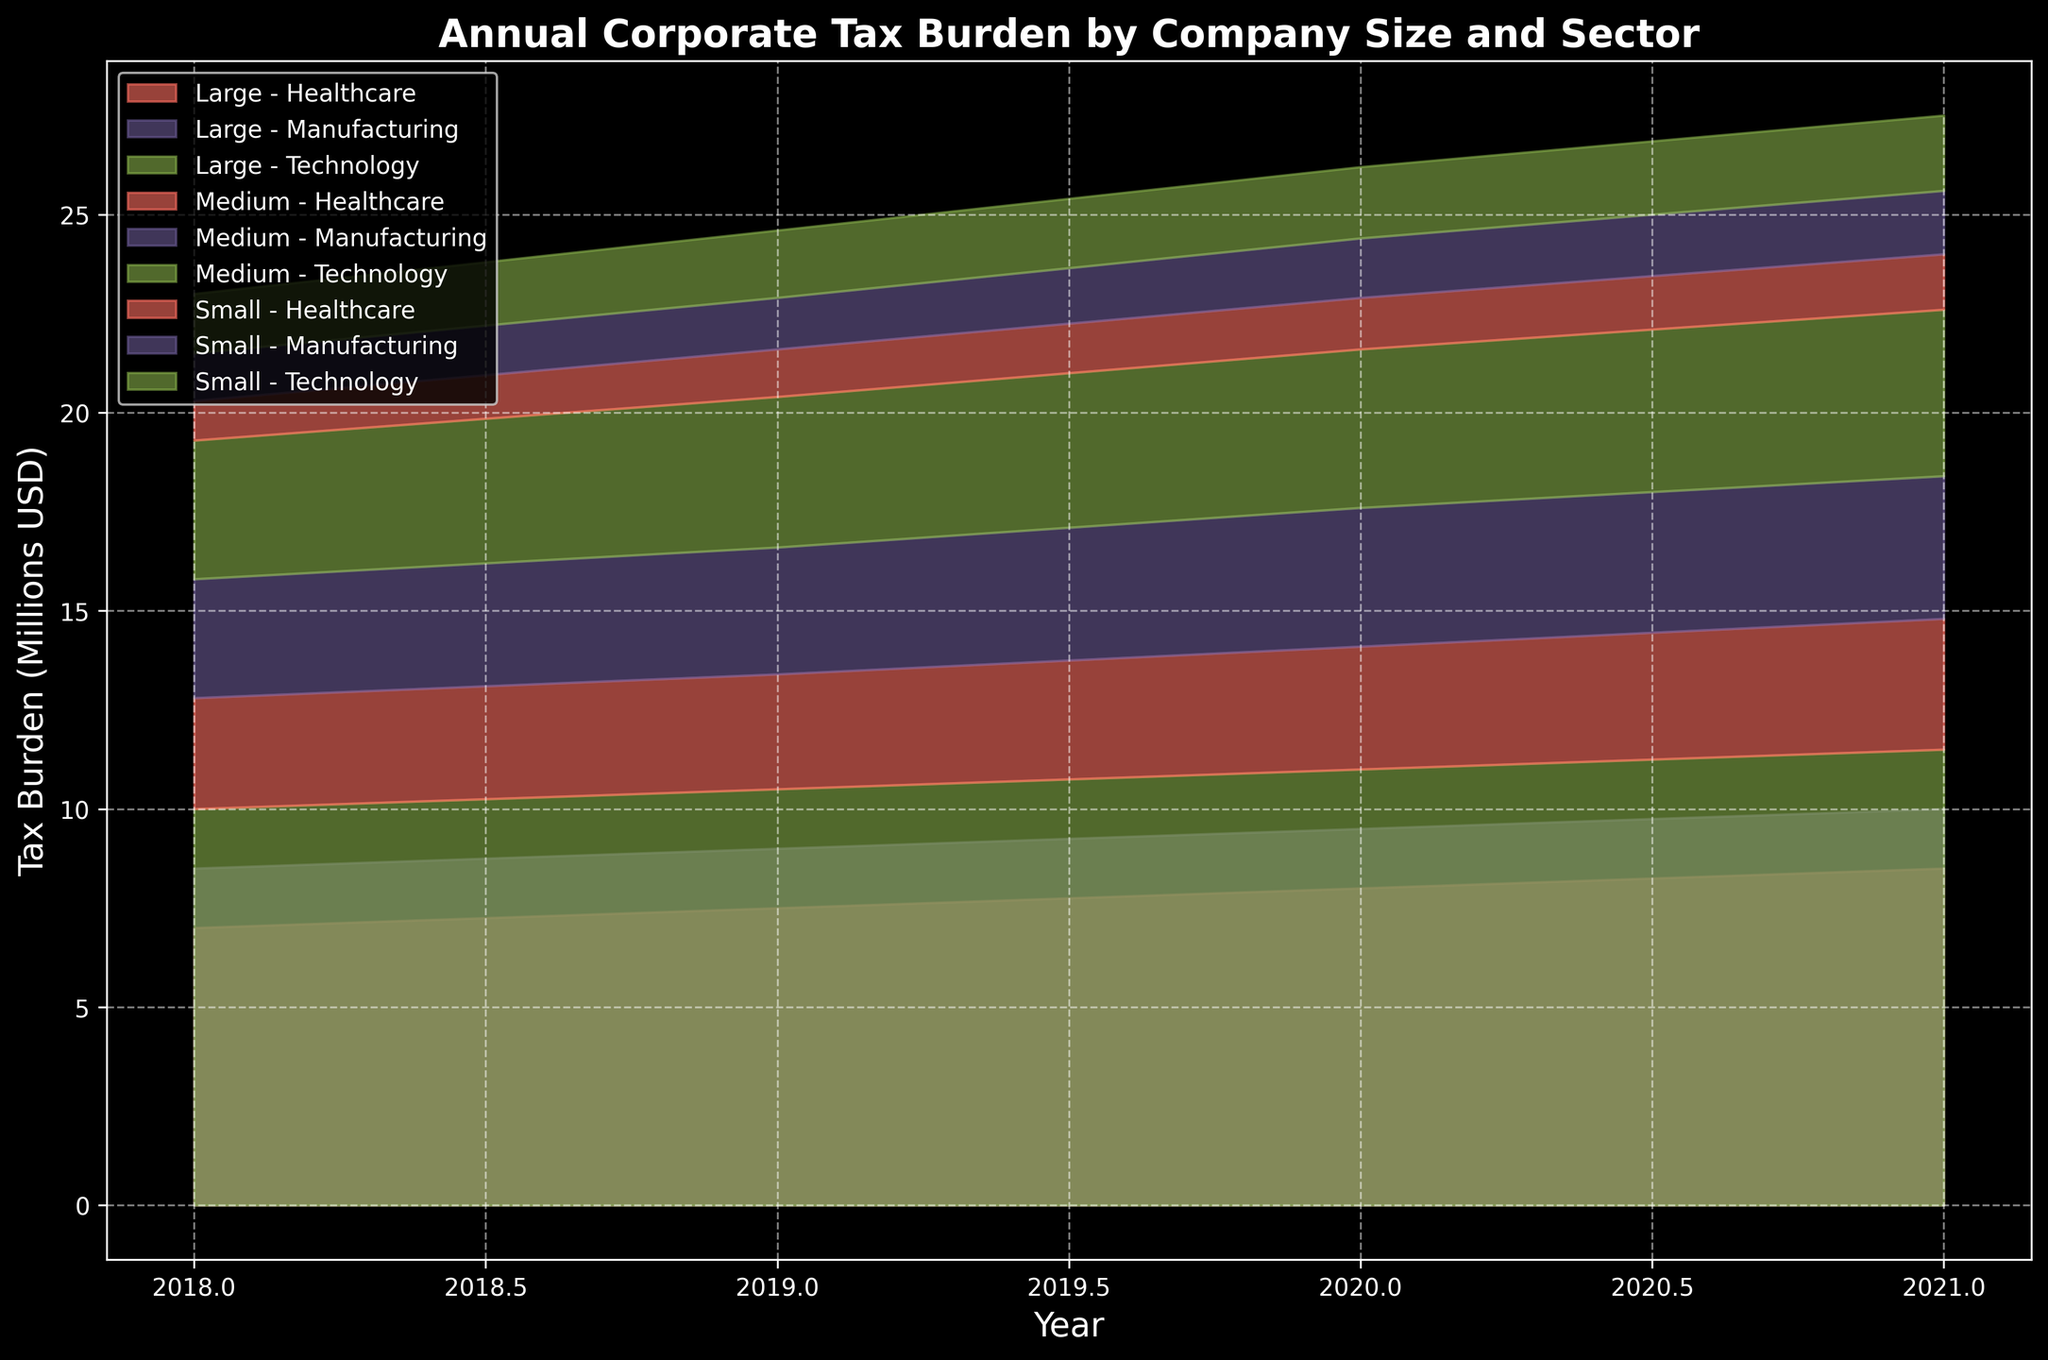What is the overall corporate tax burden trend for the Technology sector from 2018 to 2021? The figure shows a consistent upward slope for the Technology sector indicating a steady increase in the tax burden from 2018 to 2021. For example, in 2018, the corporate tax burden for Technology was significantly lower compared to 2021.
Answer: Increasing Which company size in the Manufacturing sector has the highest tax burden in 2021? In 2021, the area representing the large companies in Manufacturing is the tallest in the Manufacturing sector, indicating that it has the highest tax burden compared to small and medium-sized companies.
Answer: Large How does the tax burden for small companies in the Healthcare sector in 2019 compare to that in the Technology sector in the same year? By comparing the heights of the areas in the figure, we can see that the tax burden for small companies in the Healthcare sector in 2019 is lower than that in the Technology sector.
Answer: Lower What is the total corporate tax burden for medium-sized companies in all sectors in 2020? To find the total, sum the tax burdens for medium-sized companies in Technology, Manufacturing, and Healthcare sectors in 2020. The combined height of those areas represents the total, which is 4.0 (Technology) + 3.5 (Manufacturing) + 3.1 (Healthcare).
Answer: 10.6 Million USD Which sector had the highest increase in tax burden from 2018 to 2021 for large companies? The figure shows that the Healthcare sector has the steepest increase in the area representing large companies from 2018 to 2021.
Answer: Healthcare Compare the trend of the corporate tax burden for medium and large companies in the Manufacturing sector from 2018 to 2021. Both medium and large companies in the Manufacturing sector display an increasing trend, but the increase for large companies is more pronounced compared to medium companies, as seen by the steeper slope in the area representing large companies.
Answer: Large companies increased more What is the difference in the corporate tax burden between small and large companies in the Technology sector in 2020? By looking at the heights of the respective areas, the tax burden for small companies is 1.8 while for large companies is 11.0 in 2020. The difference is calculated as 11.0 - 1.8.
Answer: 9.2 Million USD How does the pattern of tax burden changes for medium companies compare across all sectors from 2018 to 2021? The figure shows a similar pattern across all sectors where the tax burden for medium companies gradually increases from 2018 to 2021, albeit at different rates.
Answer: Gradual increase 